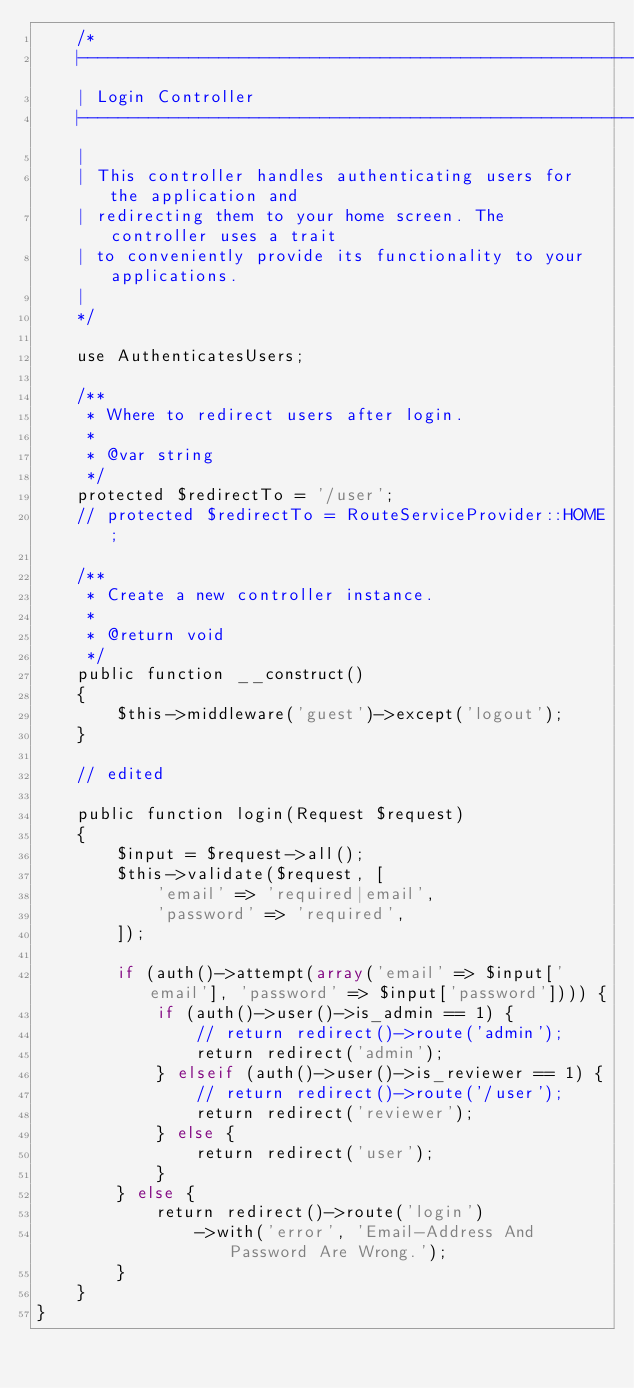<code> <loc_0><loc_0><loc_500><loc_500><_PHP_>    /*
    |--------------------------------------------------------------------------
    | Login Controller
    |--------------------------------------------------------------------------
    |
    | This controller handles authenticating users for the application and
    | redirecting them to your home screen. The controller uses a trait
    | to conveniently provide its functionality to your applications.
    |
    */

    use AuthenticatesUsers;

    /**
     * Where to redirect users after login.
     *
     * @var string
     */
    protected $redirectTo = '/user';
    // protected $redirectTo = RouteServiceProvider::HOME;

    /**
     * Create a new controller instance.
     *
     * @return void
     */
    public function __construct()
    {
        $this->middleware('guest')->except('logout');
    }

    // edited

    public function login(Request $request)
    {
        $input = $request->all();
        $this->validate($request, [
            'email' => 'required|email',
            'password' => 'required',
        ]);

        if (auth()->attempt(array('email' => $input['email'], 'password' => $input['password']))) {
            if (auth()->user()->is_admin == 1) {
                // return redirect()->route('admin');
                return redirect('admin');
            } elseif (auth()->user()->is_reviewer == 1) {
                // return redirect()->route('/user');
                return redirect('reviewer');
            } else {
                return redirect('user');
            }
        } else {
            return redirect()->route('login')
                ->with('error', 'Email-Address And Password Are Wrong.');
        }
    }
}
</code> 